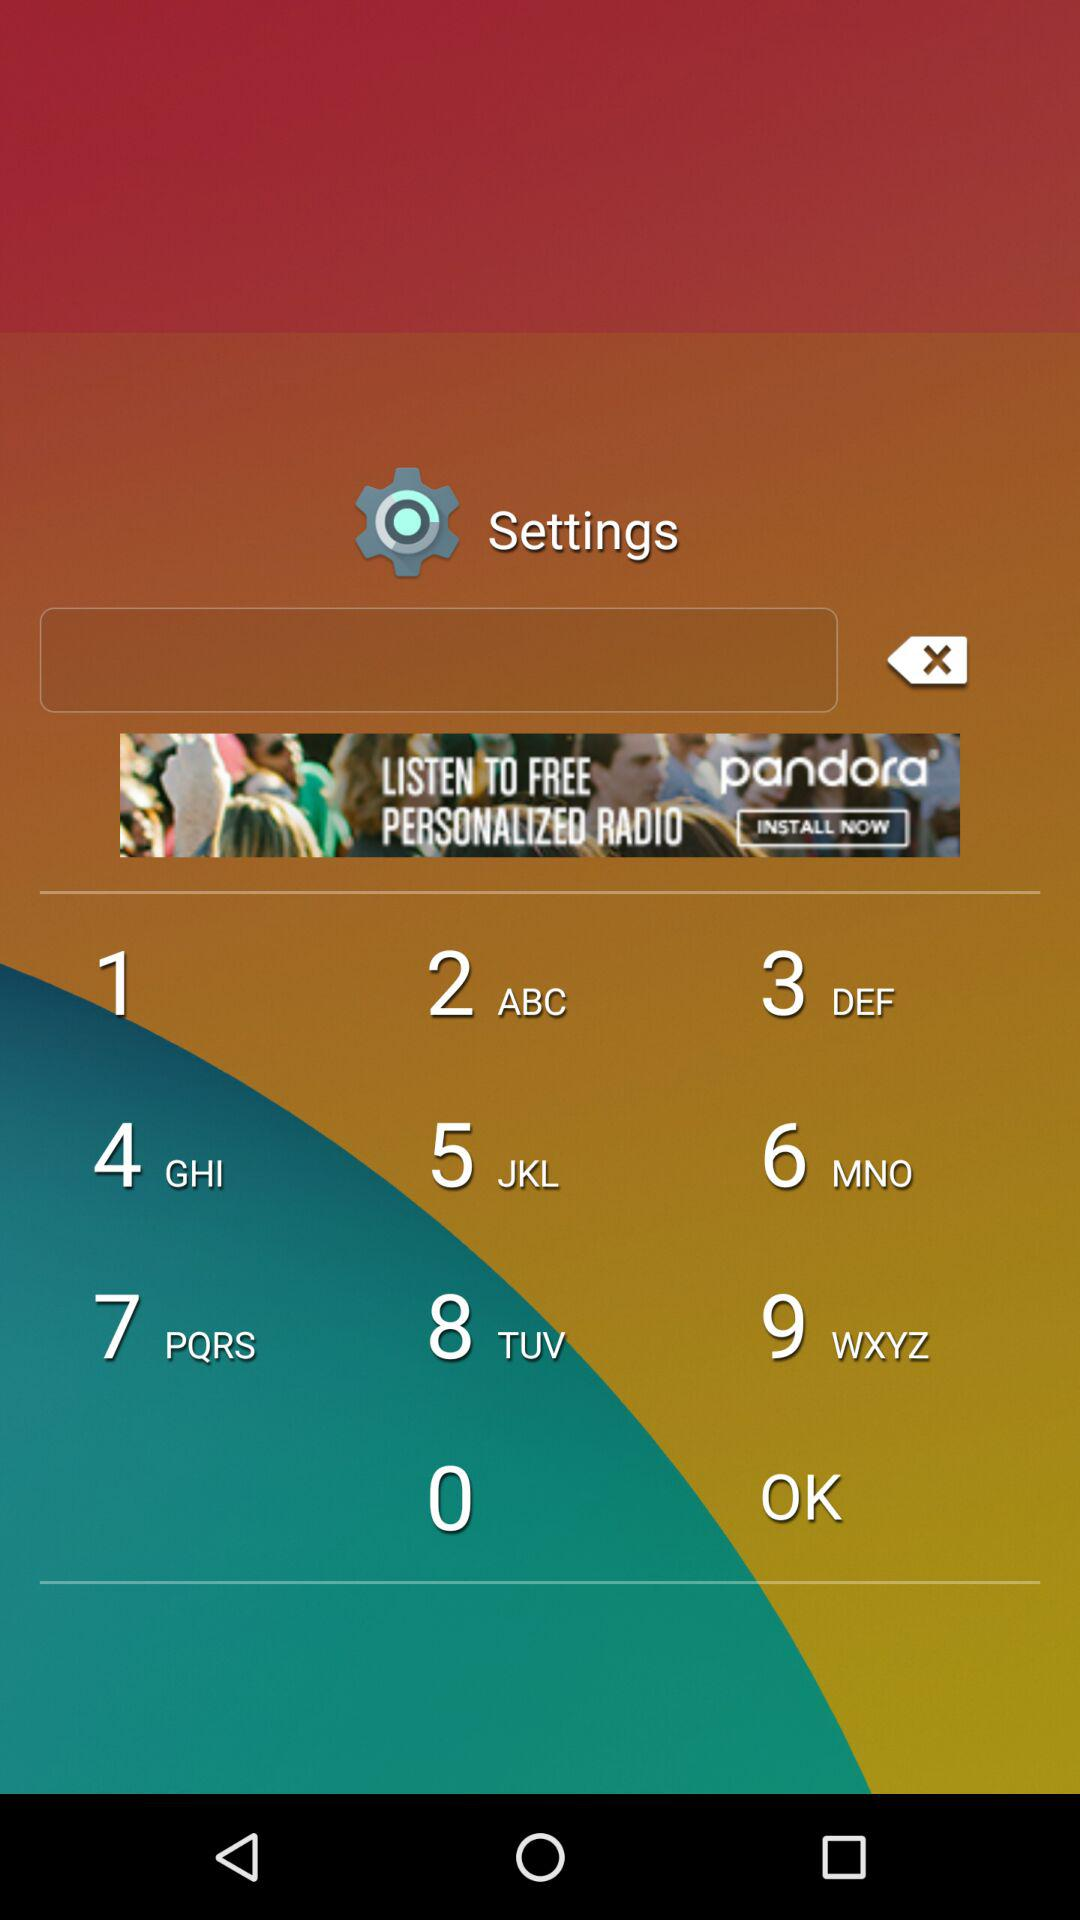What is the name of the application? The name of the application is "n-gage". 